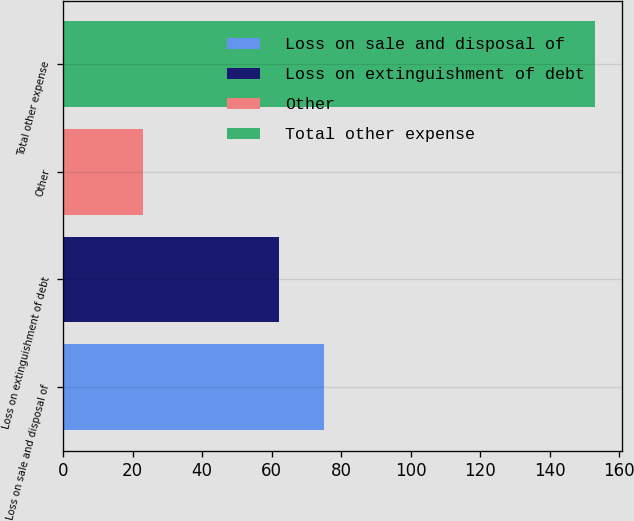Convert chart to OTSL. <chart><loc_0><loc_0><loc_500><loc_500><bar_chart><fcel>Loss on sale and disposal of<fcel>Loss on extinguishment of debt<fcel>Other<fcel>Total other expense<nl><fcel>75<fcel>62<fcel>23<fcel>153<nl></chart> 